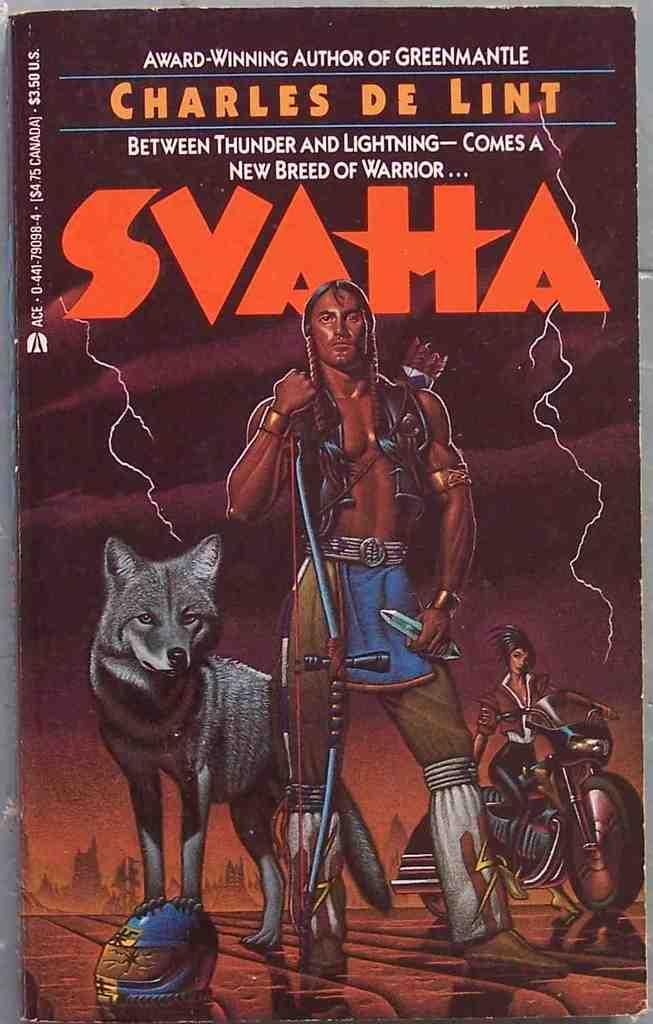What is the main subject of the book cover in the image? The book cover has pictures of people, a wolf, a motorbike, and a helmet on it. Are there any words on the book cover? Yes, there are words on the book cover. What type of images can be seen on the book cover? The book cover has pictures of people, a wolf, a motorbike, and a helmet. What type of pet is depicted on the book cover? There is no pet depicted on the book cover; it features pictures of people, a wolf, a motorbike, and a helmet. Who is the representative of the book cover? The book cover does not have a specific representative; it is a visual representation of the book's content. 